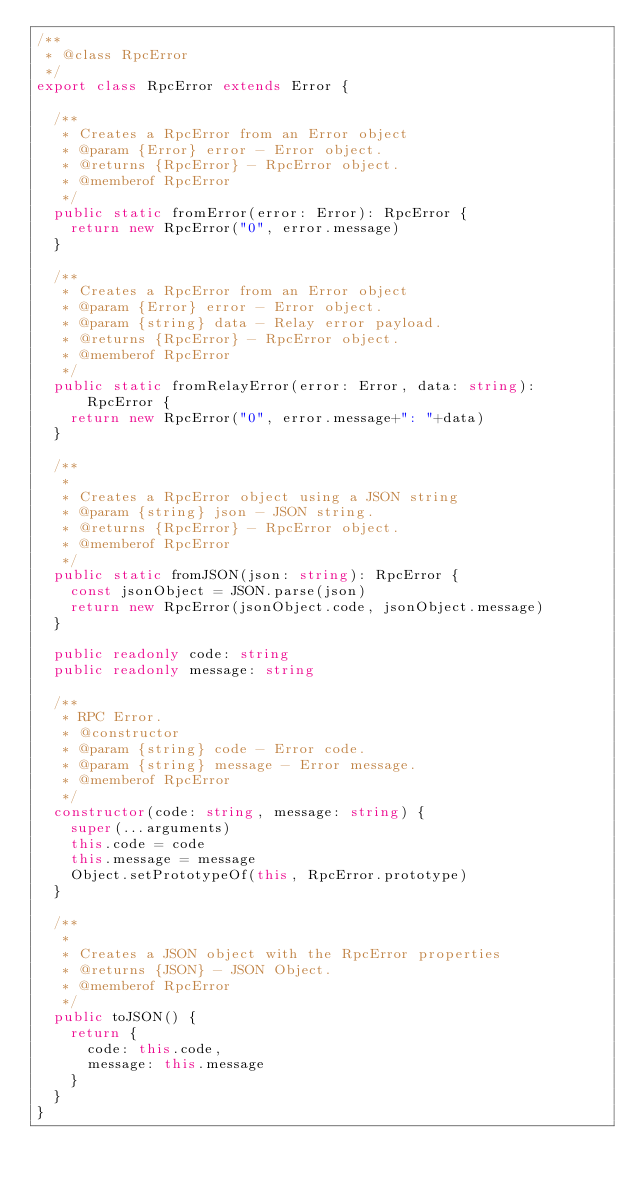Convert code to text. <code><loc_0><loc_0><loc_500><loc_500><_TypeScript_>/**
 * @class RpcError
 */
export class RpcError extends Error {

  /**
   * Creates a RpcError from an Error object
   * @param {Error} error - Error object.
   * @returns {RpcError} - RpcError object.
   * @memberof RpcError
   */
  public static fromError(error: Error): RpcError {
    return new RpcError("0", error.message)
  }

  /**
   * Creates a RpcError from an Error object
   * @param {Error} error - Error object.
   * @param {string} data - Relay error payload.
   * @returns {RpcError} - RpcError object.
   * @memberof RpcError
   */
  public static fromRelayError(error: Error, data: string): RpcError {
    return new RpcError("0", error.message+": "+data)
  }

  /**
   *
   * Creates a RpcError object using a JSON string
   * @param {string} json - JSON string.
   * @returns {RpcError} - RpcError object.
   * @memberof RpcError
   */
  public static fromJSON(json: string): RpcError {
    const jsonObject = JSON.parse(json)
    return new RpcError(jsonObject.code, jsonObject.message)
  }

  public readonly code: string
  public readonly message: string

  /**
   * RPC Error.
   * @constructor
   * @param {string} code - Error code.
   * @param {string} message - Error message.
   * @memberof RpcError
   */
  constructor(code: string, message: string) {
    super(...arguments)
    this.code = code
    this.message = message
    Object.setPrototypeOf(this, RpcError.prototype)
  }

  /**
   *
   * Creates a JSON object with the RpcError properties
   * @returns {JSON} - JSON Object.
   * @memberof RpcError
   */
  public toJSON() {
    return {
      code: this.code,
      message: this.message
    }
  }
}
</code> 